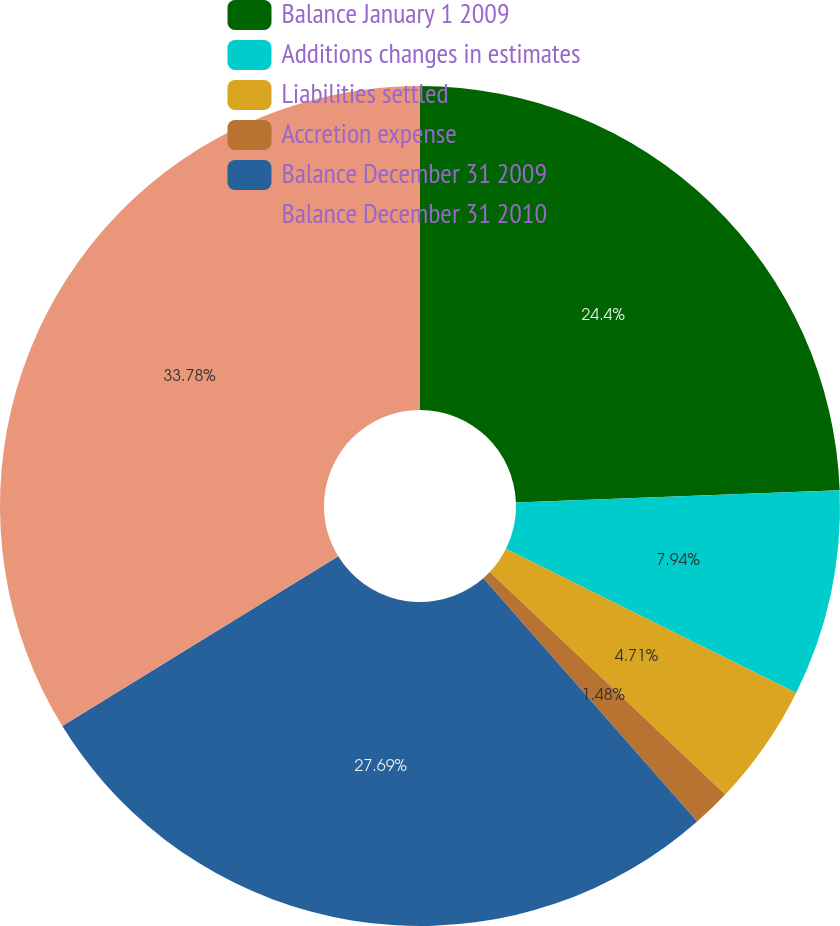Convert chart to OTSL. <chart><loc_0><loc_0><loc_500><loc_500><pie_chart><fcel>Balance January 1 2009<fcel>Additions changes in estimates<fcel>Liabilities settled<fcel>Accretion expense<fcel>Balance December 31 2009<fcel>Balance December 31 2010<nl><fcel>24.4%<fcel>7.94%<fcel>4.71%<fcel>1.48%<fcel>27.69%<fcel>33.78%<nl></chart> 